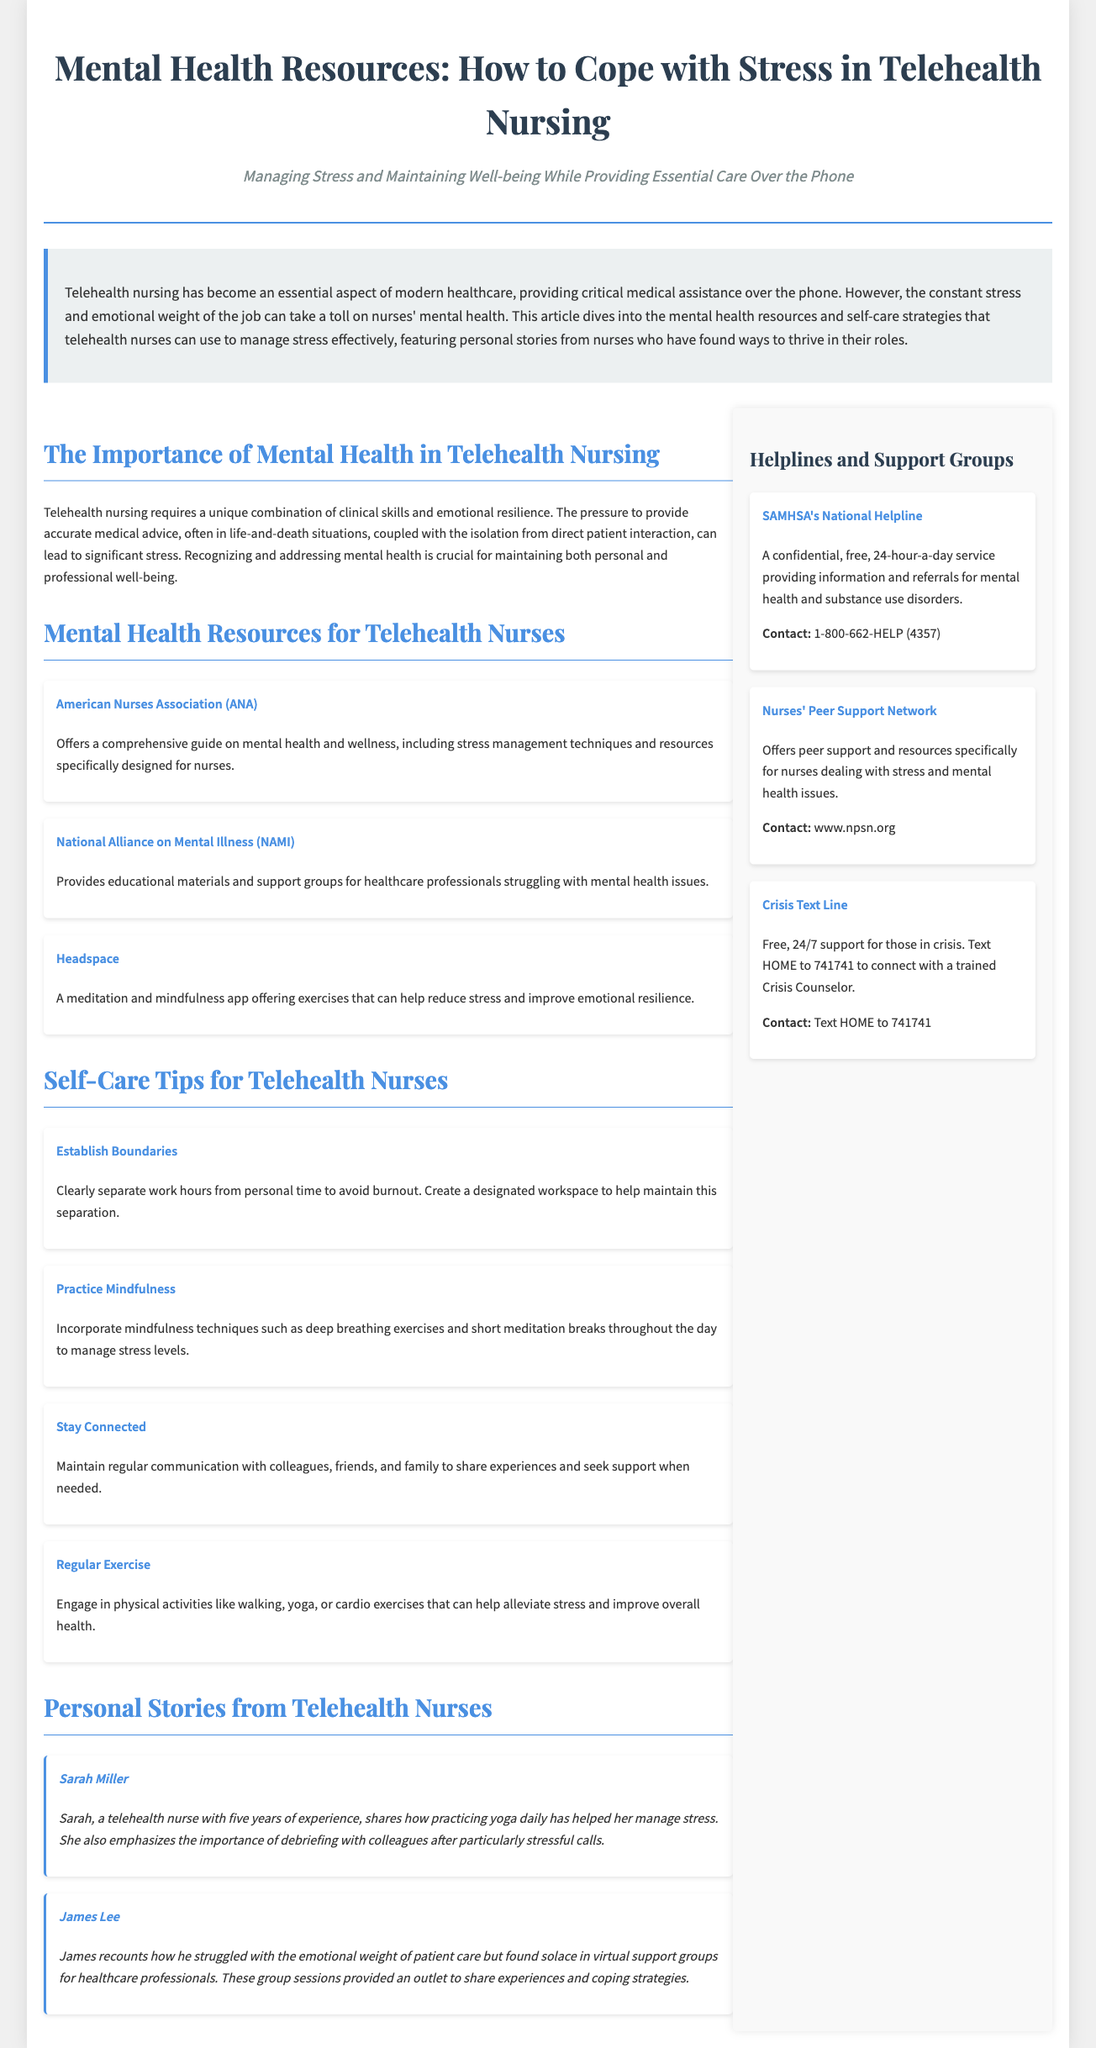what is the title of the article? The title is prominently displayed at the top of the document, highlighting the focus on mental health resources for telehealth nursing.
Answer: Mental Health Resources: How to Cope with Stress in Telehealth Nursing who is the author of the personal story about yoga? The document features personal stories from telehealth nurses, and one story mentions a nurse named Sarah who practices yoga.
Answer: Sarah Miller which organization provides resources specifically designed for nurses? The document lists several organizations, highlighting those that cater specifically to nurses' mental health and wellness.
Answer: American Nurses Association (ANA) how can telehealth nurses practice mindfulness? The document provides self-care tips, one of which focuses on incorporating mindfulness techniques into daily routines.
Answer: Deep breathing exercises and short meditation breaks what is the contact method for the Crisis Text Line? The helplines section describes how individuals in crisis can reach out for support through a specific texting system.
Answer: Text HOME to 741741 what is one self-care tip mentioned in the article? The article includes several self-care tips for telehealth nurses to help manage stress effectively.
Answer: Establish Boundaries what is the purpose of the sidebar in the document? The sidebar contains critical information and resources to support telehealth nurses, offering quick access to helplines and support.
Answer: Helplines and Support Groups how many personal stories are featured in the article? The document includes two personal stories from telehealth nurses sharing their experiences and coping strategies.
Answer: Two 